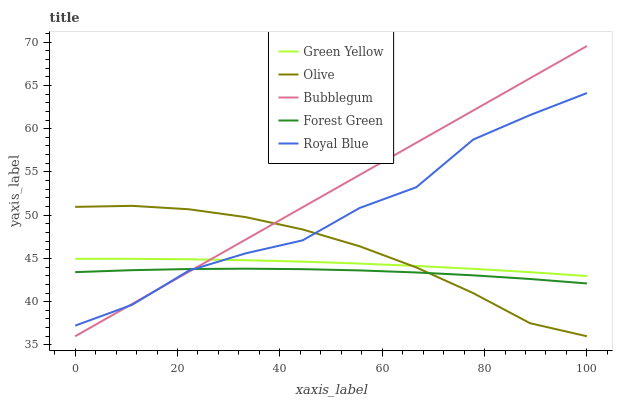Does Forest Green have the minimum area under the curve?
Answer yes or no. Yes. Does Bubblegum have the maximum area under the curve?
Answer yes or no. Yes. Does Royal Blue have the minimum area under the curve?
Answer yes or no. No. Does Royal Blue have the maximum area under the curve?
Answer yes or no. No. Is Bubblegum the smoothest?
Answer yes or no. Yes. Is Royal Blue the roughest?
Answer yes or no. Yes. Is Forest Green the smoothest?
Answer yes or no. No. Is Forest Green the roughest?
Answer yes or no. No. Does Royal Blue have the lowest value?
Answer yes or no. No. Does Royal Blue have the highest value?
Answer yes or no. No. Is Forest Green less than Green Yellow?
Answer yes or no. Yes. Is Green Yellow greater than Forest Green?
Answer yes or no. Yes. Does Forest Green intersect Green Yellow?
Answer yes or no. No. 